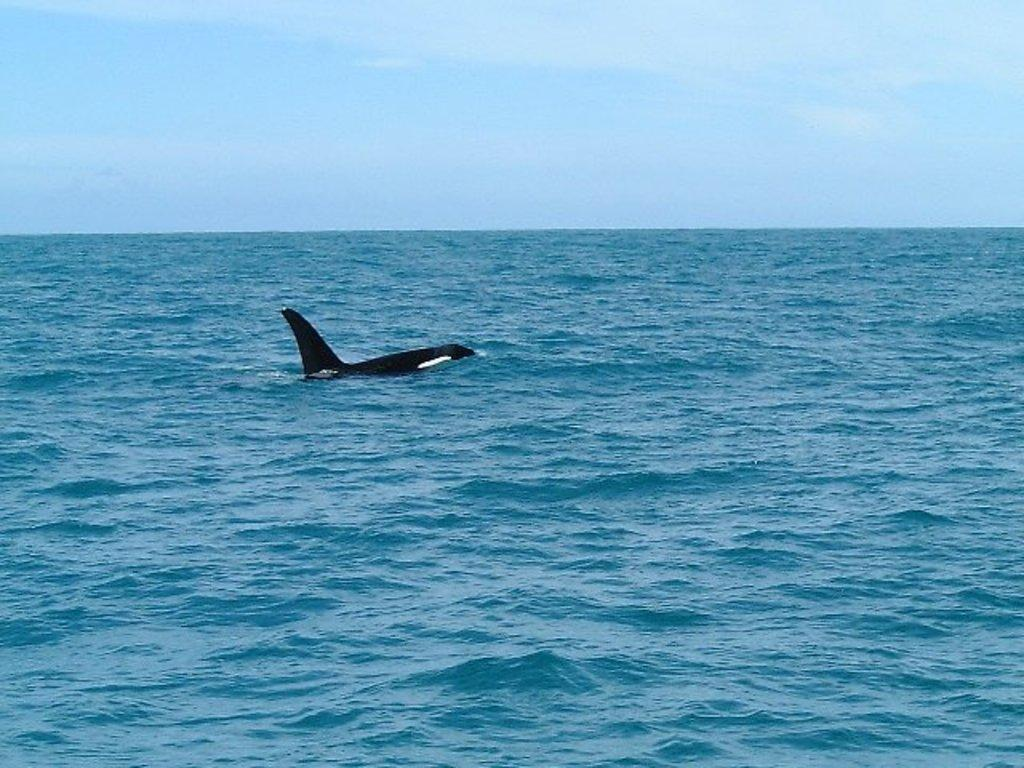What is the main subject of the image? The main subject of the image is a dolphin. Where is the dolphin located? The dolphin is in the sea. What type of detail can be seen on the dolphin's skin in the image? There is no specific detail mentioned on the dolphin's skin in the provided facts. What type of pies are being served on the boat in the image? There is no boat or pies present in the image; it features a dolphin in the sea. What type of wax is used to create the dolphin sculpture in the image? There is no mention of a sculpture or wax in the provided facts; the image features a real dolphin in the sea. 